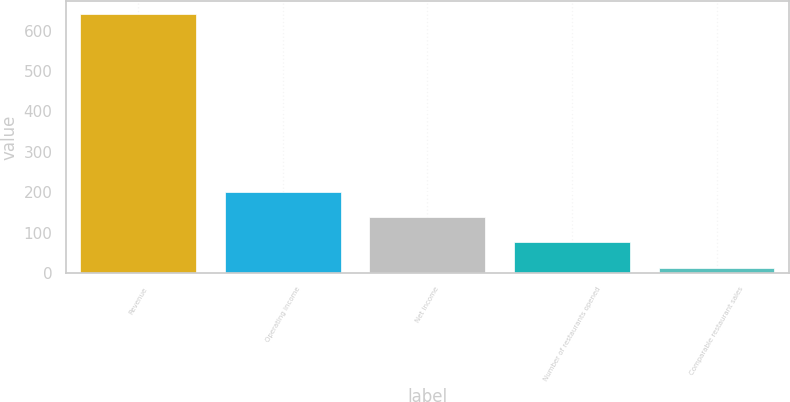Convert chart to OTSL. <chart><loc_0><loc_0><loc_500><loc_500><bar_chart><fcel>Revenue<fcel>Operating income<fcel>Net income<fcel>Number of restaurants opened<fcel>Comparable restaurant sales<nl><fcel>640.6<fcel>201.07<fcel>138.28<fcel>75.49<fcel>12.7<nl></chart> 